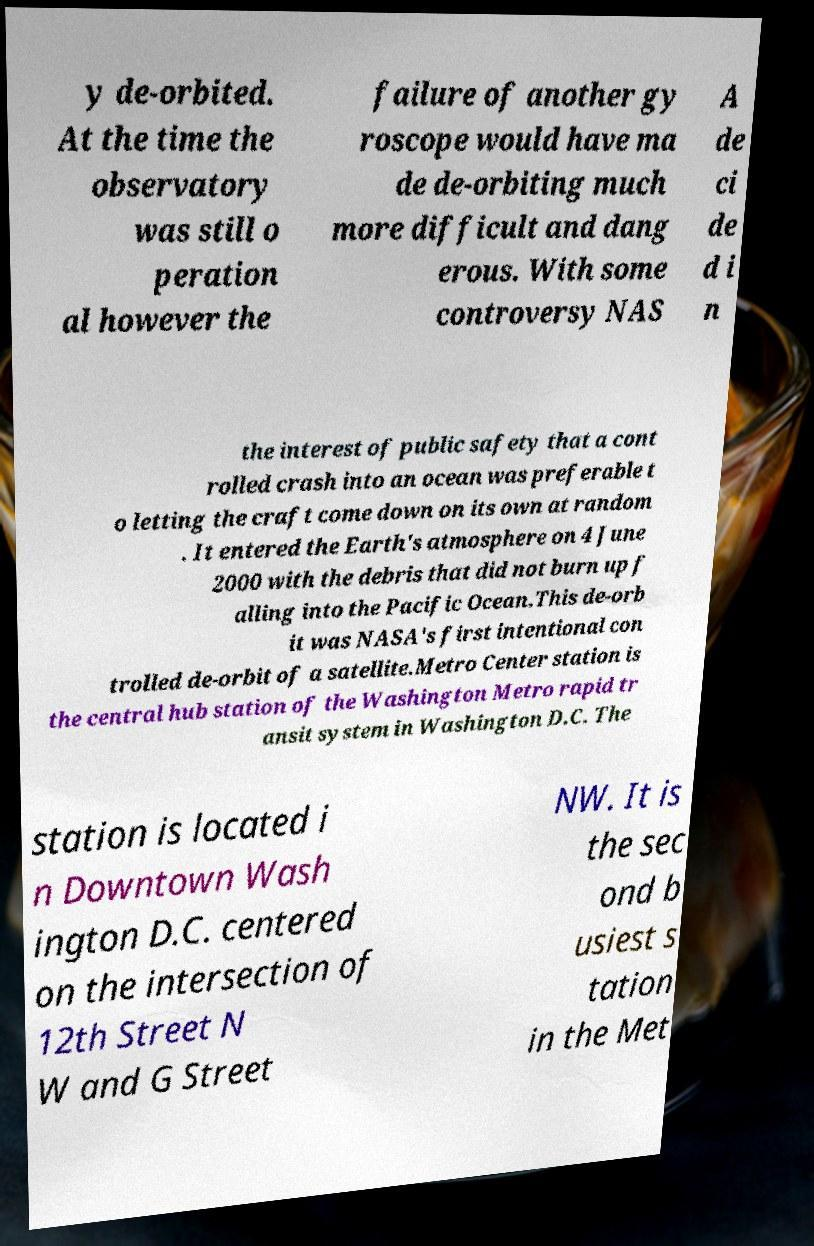I need the written content from this picture converted into text. Can you do that? y de-orbited. At the time the observatory was still o peration al however the failure of another gy roscope would have ma de de-orbiting much more difficult and dang erous. With some controversy NAS A de ci de d i n the interest of public safety that a cont rolled crash into an ocean was preferable t o letting the craft come down on its own at random . It entered the Earth's atmosphere on 4 June 2000 with the debris that did not burn up f alling into the Pacific Ocean.This de-orb it was NASA's first intentional con trolled de-orbit of a satellite.Metro Center station is the central hub station of the Washington Metro rapid tr ansit system in Washington D.C. The station is located i n Downtown Wash ington D.C. centered on the intersection of 12th Street N W and G Street NW. It is the sec ond b usiest s tation in the Met 